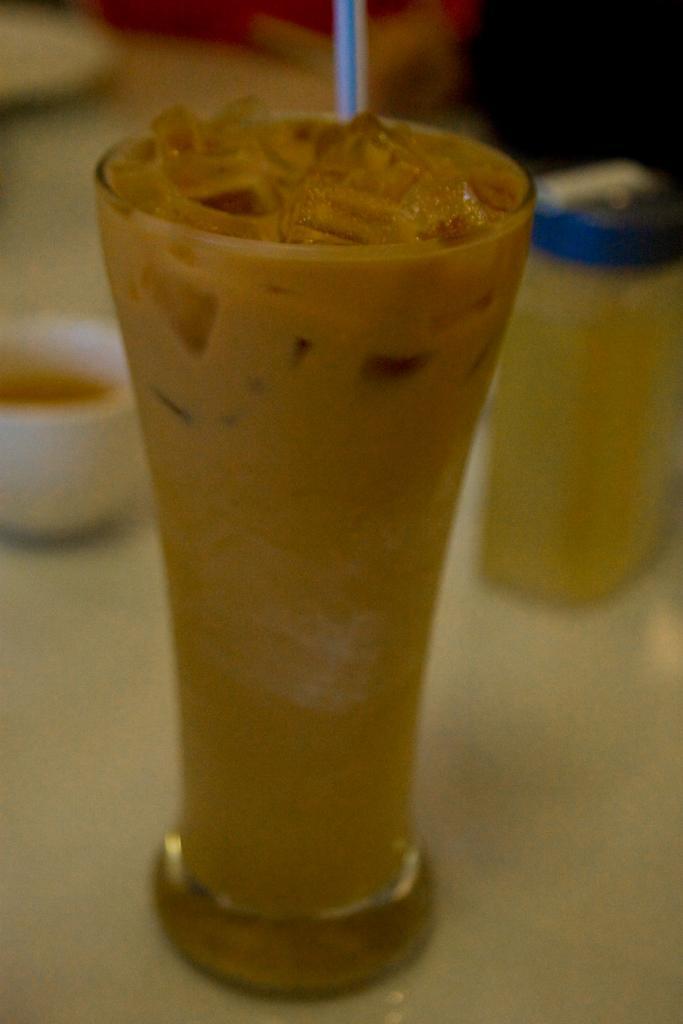Please provide a concise description of this image. In this image we can see the glass with a straw on the surface. We can also see a cup and a small bottle in this image. 